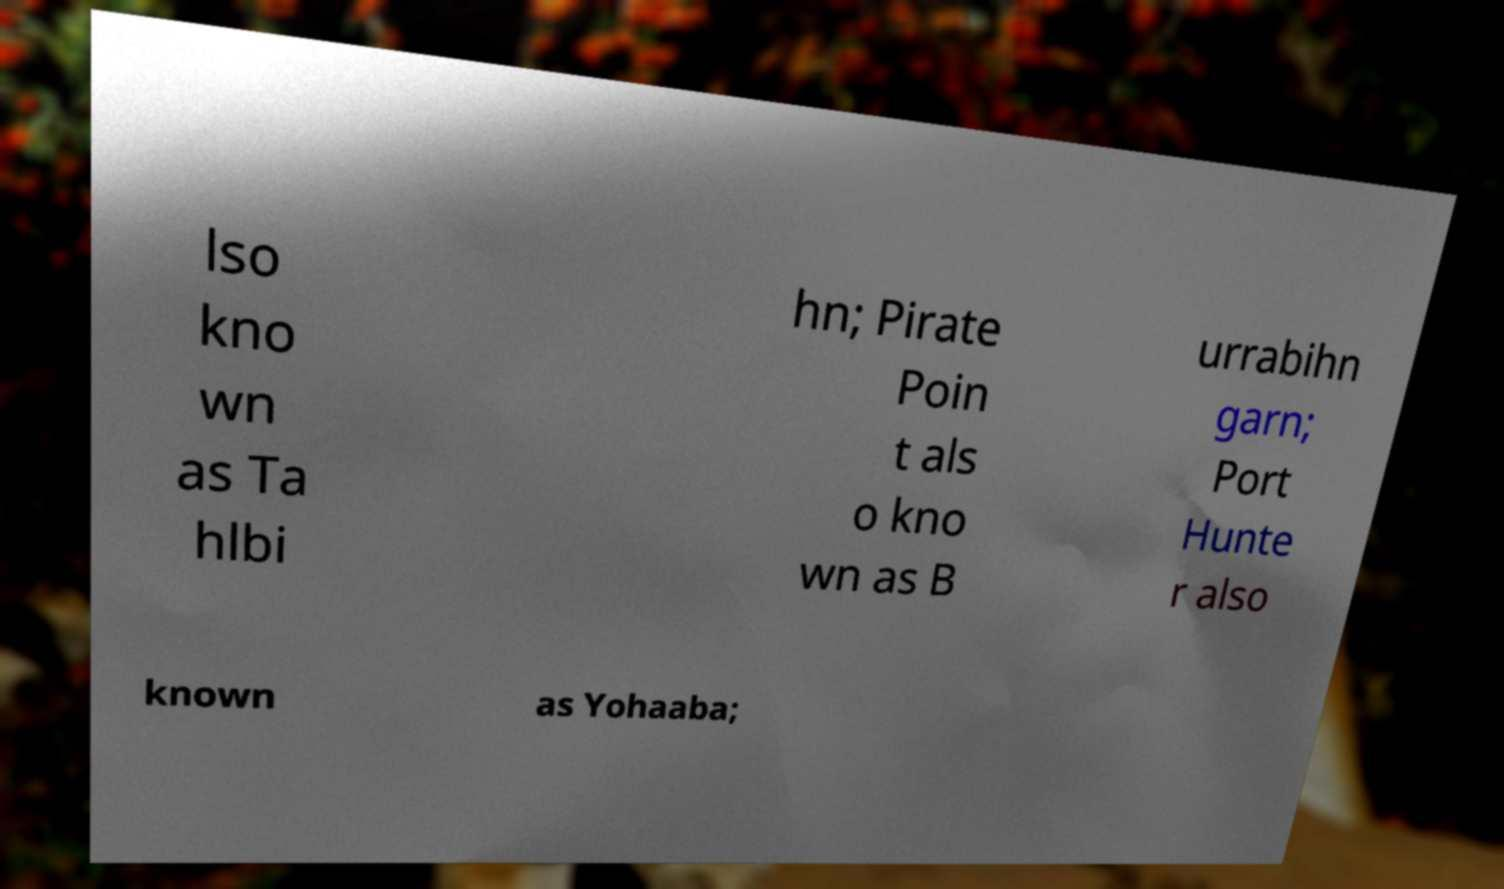I need the written content from this picture converted into text. Can you do that? lso kno wn as Ta hlbi hn; Pirate Poin t als o kno wn as B urrabihn garn; Port Hunte r also known as Yohaaba; 